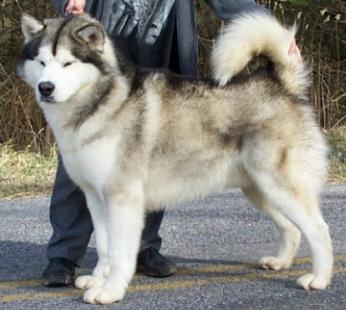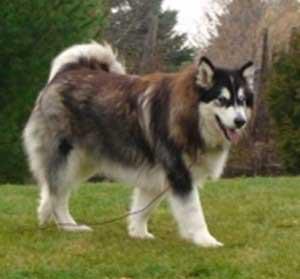The first image is the image on the left, the second image is the image on the right. Given the left and right images, does the statement "There are four dogs." hold true? Answer yes or no. No. The first image is the image on the left, the second image is the image on the right. Considering the images on both sides, is "There is a total of four dogs." valid? Answer yes or no. No. 